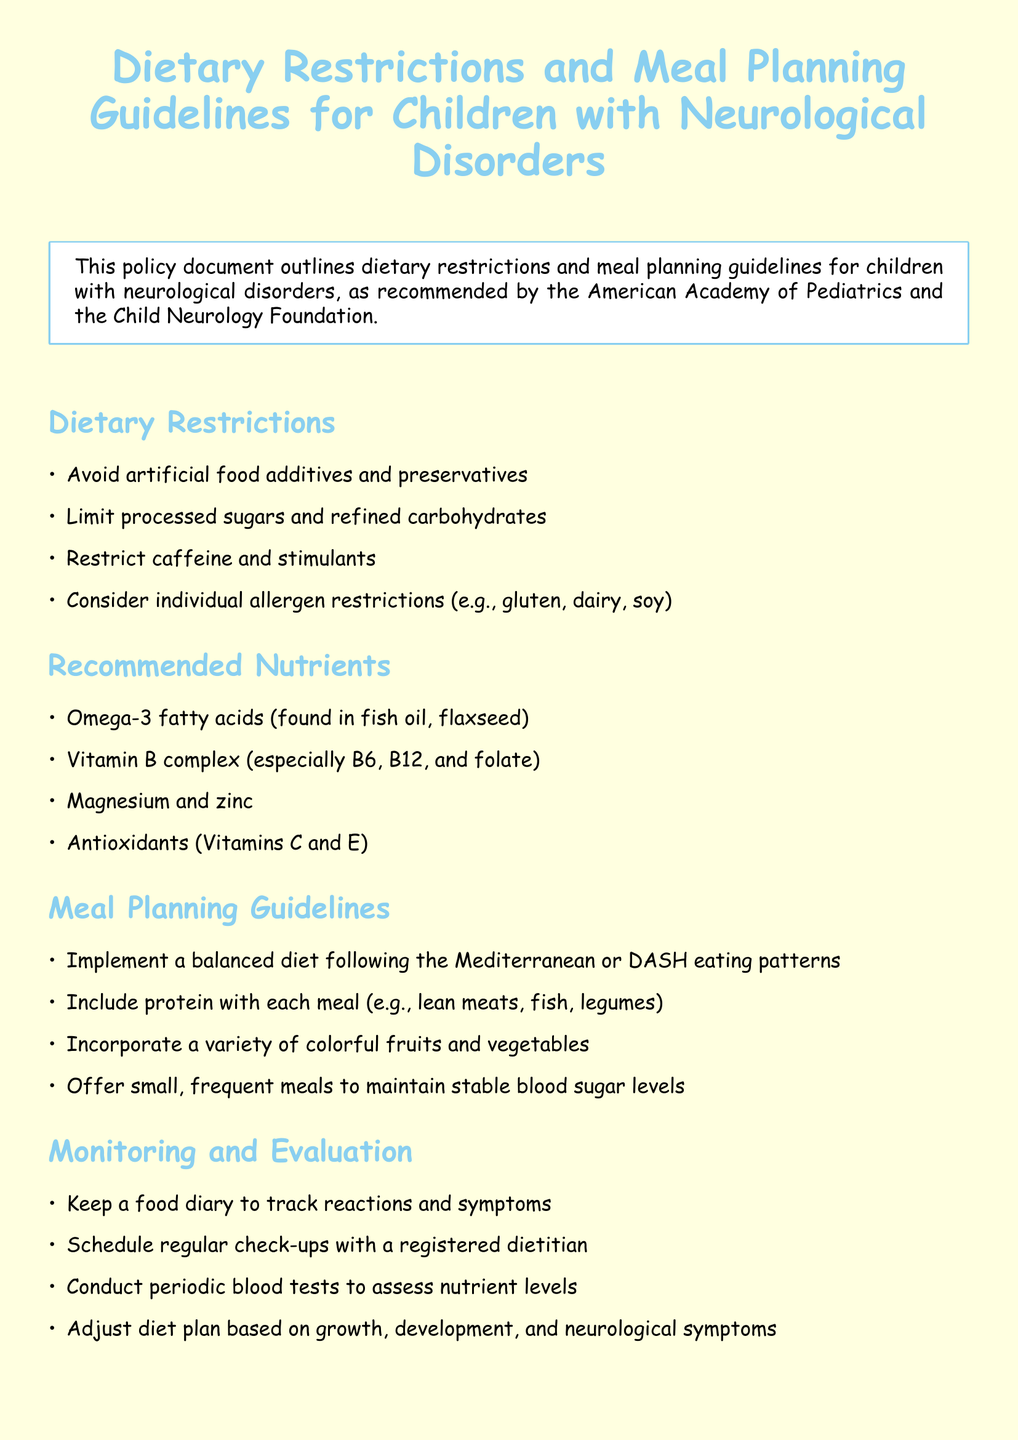what are the dietary restrictions? The dietary restrictions include avoiding artificial food additives and preservatives, limiting processed sugars and refined carbohydrates, restricting caffeine and stimulants, and considering individual allergen restrictions.
Answer: avoid artificial food additives and preservatives, limit processed sugars, restrict caffeine, consider individual allergen restrictions what nutrients are recommended? The recommended nutrients include omega-3 fatty acids, vitamin B complex, magnesium, zinc, and antioxidants.
Answer: omega-3 fatty acids, vitamin B complex, magnesium, zinc, antioxidants how often should meals be offered? The document suggests offering small, frequent meals to maintain stable blood sugar levels.
Answer: small, frequent meals what is the purpose of keeping a food diary? The purpose of keeping a food diary is to track reactions and symptoms related to the diet.
Answer: track reactions and symptoms who should be consulted for children on anticonvulsant medications? For children on anticonvulsant medications, it is advised to consult with a neurologist regarding drug-nutrient interactions.
Answer: neurologist what is the document's main focus? The main focus of the document is dietary restrictions and meal planning guidelines for children with neurological disorders.
Answer: dietary restrictions and meal planning guidelines how many sections are in the document? The document contains five main sections: Dietary Restrictions, Recommended Nutrients, Meal Planning Guidelines, Monitoring and Evaluation, and Special Considerations.
Answer: five what dietary patterns are suggested? The document suggests following the Mediterranean or DASH eating patterns.
Answer: Mediterranean or DASH eating patterns 